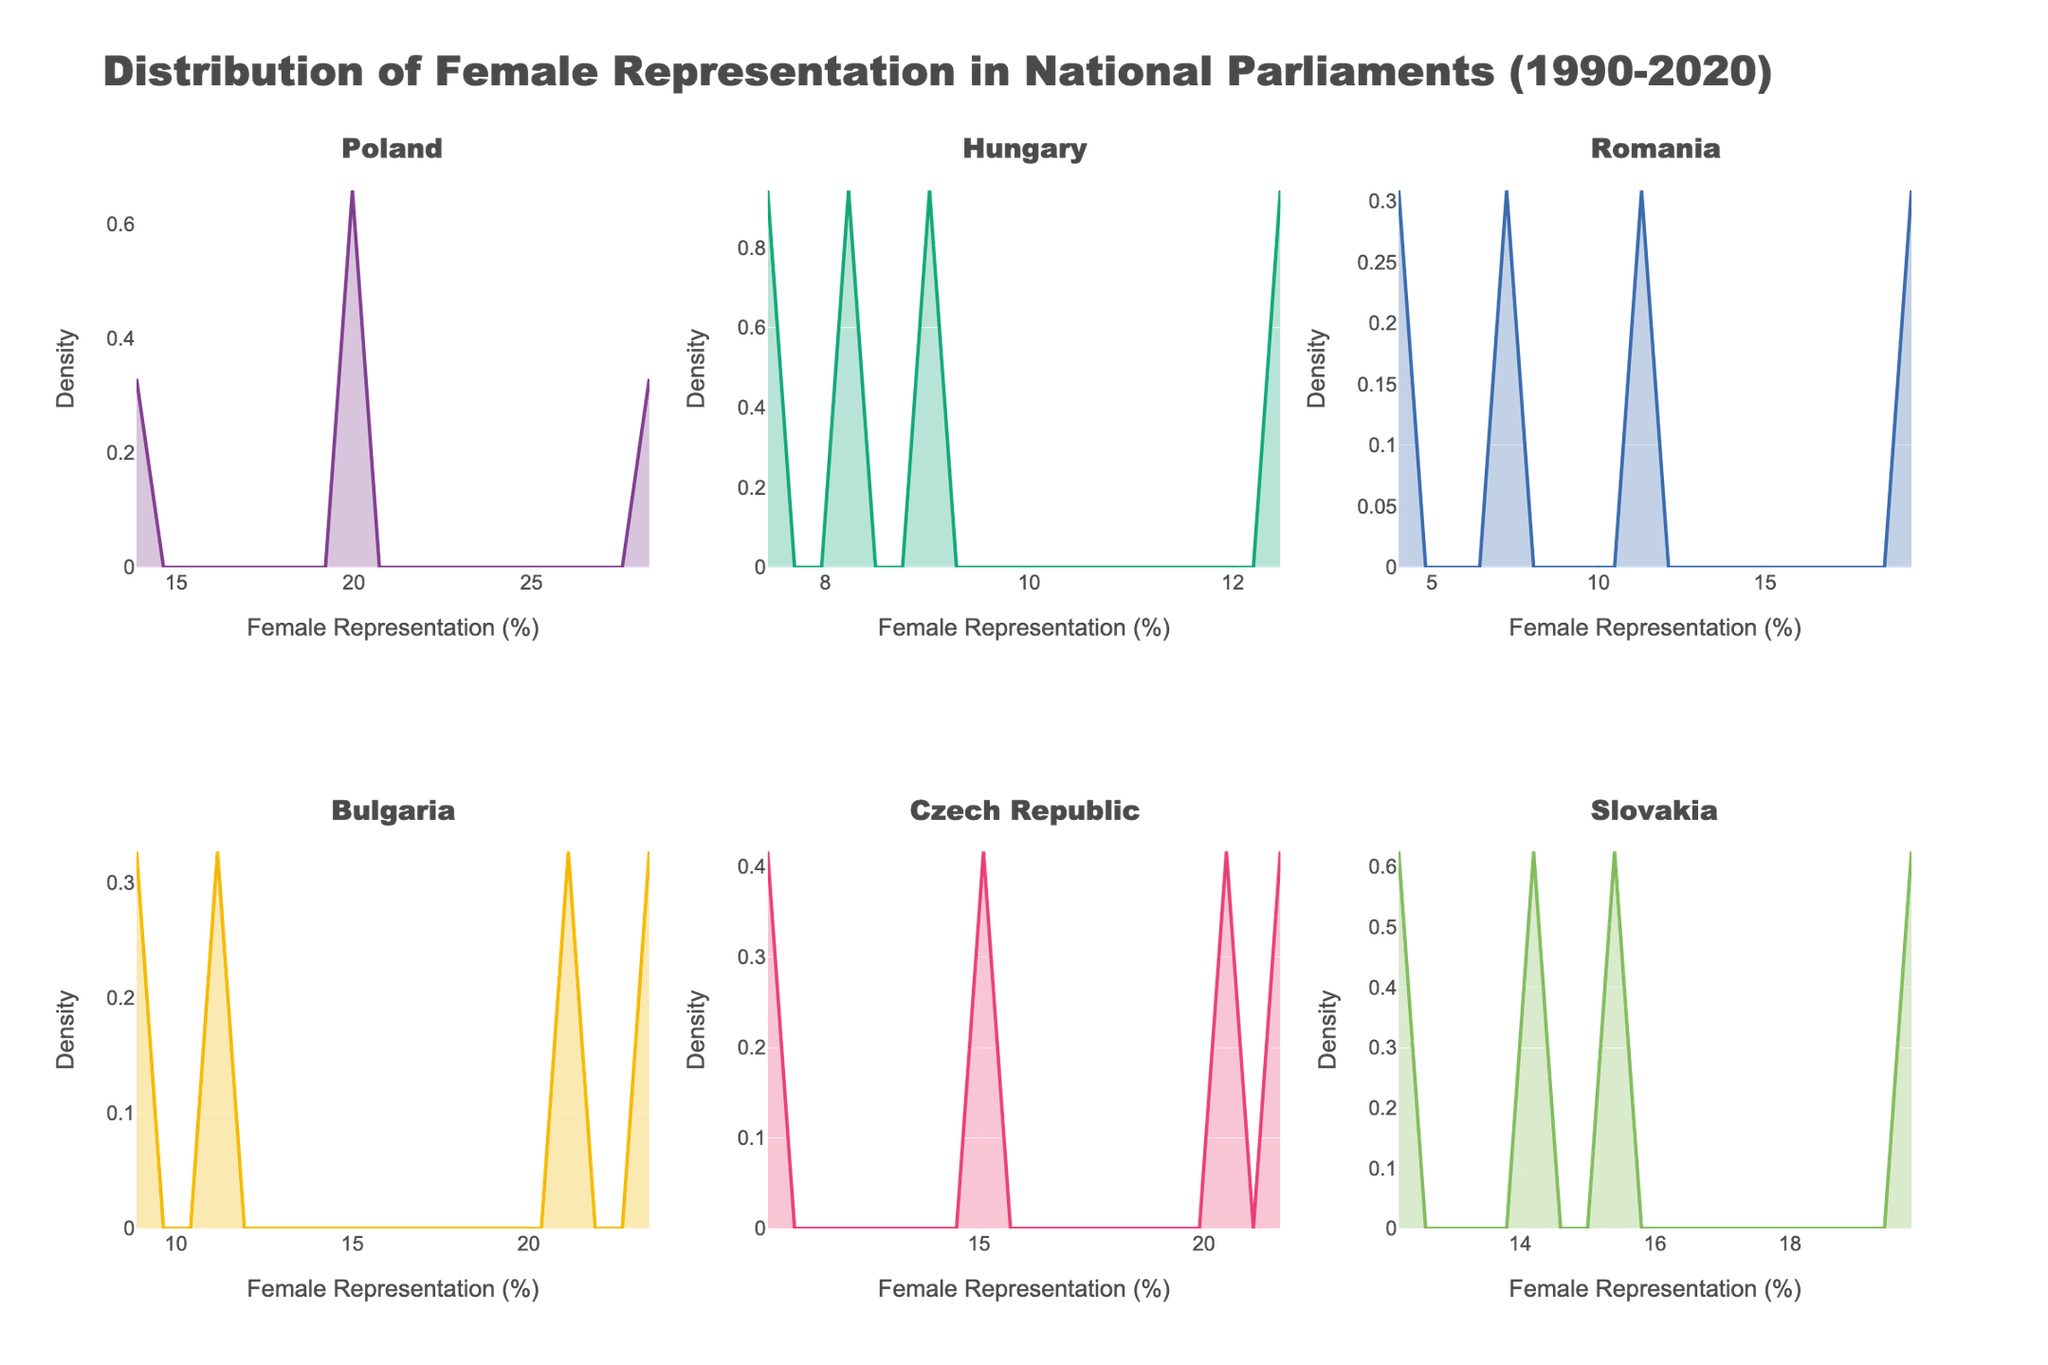What is the title of the figure? The title can be found at the top of the figure. It reads "Distribution of Female Representation in National Parliaments (1990-2020)".
Answer: Distribution of Female Representation in National Parliaments (1990-2020) Which country has the subplot in the top-left corner? The subplot titles sequentially describe the positions. The top-left corner is the first subplot, which is titled "Poland".
Answer: Poland What is the maximum female representation percentage observed for Bulgaria? The peak value on the x-axis in Bulgaria's subplot shows the maximum female representation percentage. For Bulgaria, it's approximately 23.8%.
Answer: 23.8% Which country has the lowest female representation percentage in 2020? Refer to the far-right data points on the x-axis for each subplot and identify the lowest y-value. For Hungary, the value is around 12.6%, which is the lowest.
Answer: Hungary In which year did Romania see a significant increase in female representation in parliament? By comparing the density plots over time, a significant increase is visible around 2010 in Romania's subplot. Hence, 2010 marks a significant increase.
Answer: 2010 How do the density plots for Poland and Czech Republic compare in terms of peak female representation density? Evaluating the peaks of the two subplot's density curves shows that Poland’s peak is roughly at 20%, while Czech Republic’s is slightly above that.
Answer: Czech Republic > Poland What range of female representation percentages is most densely populated for Slovakia? By examining the highest peak of Slovakia's density plot, we find it lies around 14% to 20%.
Answer: 14% to 20% Which country’s subplot shows the widest spread of female representation percentages? The country with the widest spread will have the largest range on the x-axis. By comparing all subplots, Poland shows the widest spread, ranging from about 13% to 29%.
Answer: Poland In 1990, which country had the highest representation of women in parliament? Look at the leftmost point of the x-axis for each subplot to identify the earliest year's data. The highest value in 1990 is for Poland, at approximately 13.5%.
Answer: Poland 